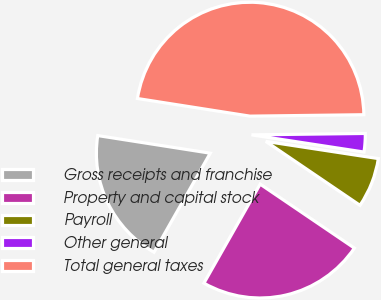Convert chart. <chart><loc_0><loc_0><loc_500><loc_500><pie_chart><fcel>Gross receipts and franchise<fcel>Property and capital stock<fcel>Payroll<fcel>Other general<fcel>Total general taxes<nl><fcel>19.25%<fcel>23.73%<fcel>7.08%<fcel>2.61%<fcel>47.33%<nl></chart> 